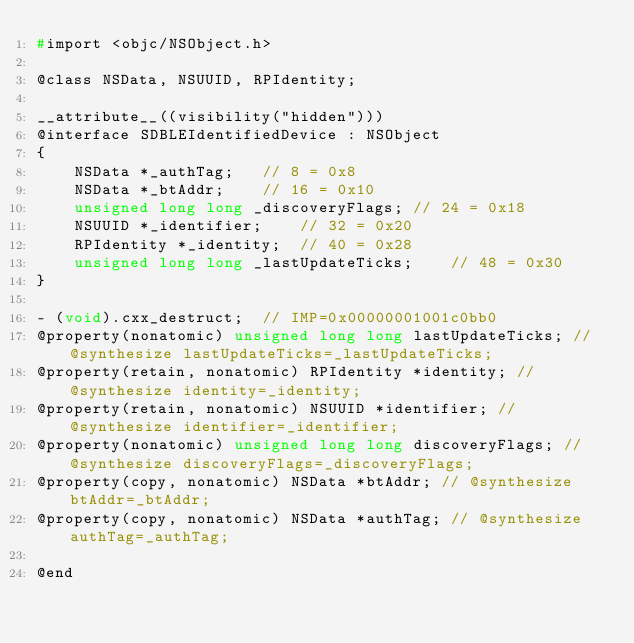Convert code to text. <code><loc_0><loc_0><loc_500><loc_500><_C_>#import <objc/NSObject.h>

@class NSData, NSUUID, RPIdentity;

__attribute__((visibility("hidden")))
@interface SDBLEIdentifiedDevice : NSObject
{
    NSData *_authTag;	// 8 = 0x8
    NSData *_btAddr;	// 16 = 0x10
    unsigned long long _discoveryFlags;	// 24 = 0x18
    NSUUID *_identifier;	// 32 = 0x20
    RPIdentity *_identity;	// 40 = 0x28
    unsigned long long _lastUpdateTicks;	// 48 = 0x30
}

- (void).cxx_destruct;	// IMP=0x00000001001c0bb0
@property(nonatomic) unsigned long long lastUpdateTicks; // @synthesize lastUpdateTicks=_lastUpdateTicks;
@property(retain, nonatomic) RPIdentity *identity; // @synthesize identity=_identity;
@property(retain, nonatomic) NSUUID *identifier; // @synthesize identifier=_identifier;
@property(nonatomic) unsigned long long discoveryFlags; // @synthesize discoveryFlags=_discoveryFlags;
@property(copy, nonatomic) NSData *btAddr; // @synthesize btAddr=_btAddr;
@property(copy, nonatomic) NSData *authTag; // @synthesize authTag=_authTag;

@end

</code> 